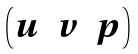<formula> <loc_0><loc_0><loc_500><loc_500>\begin{pmatrix} u & v & p \end{pmatrix}</formula> 